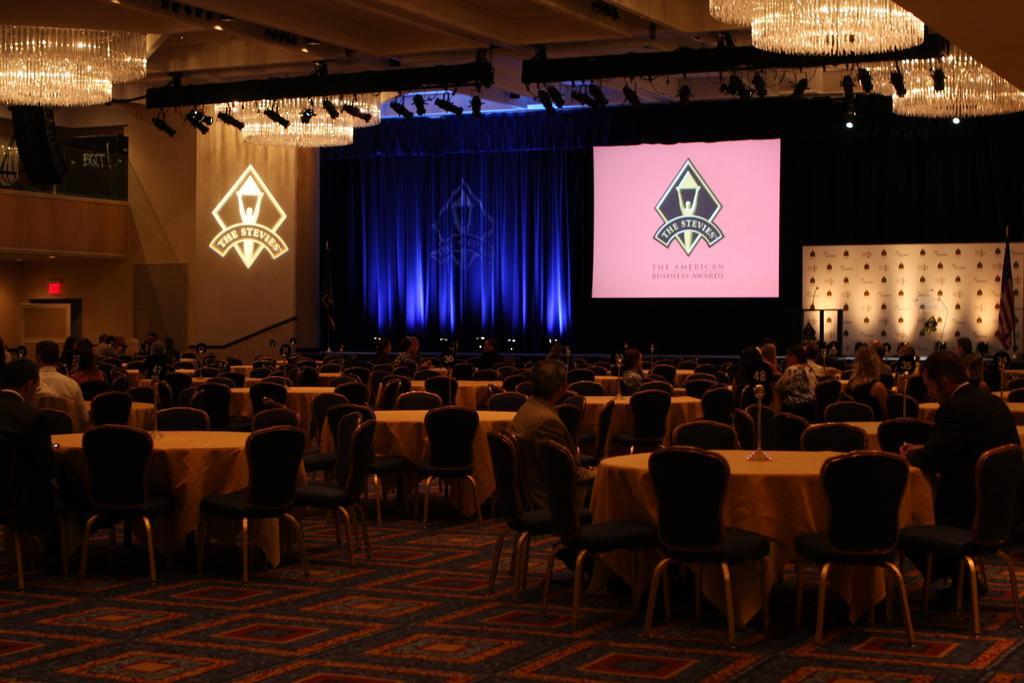Can you describe this image briefly? Here we can see a hall full of tables and chairs and people sitting on them, at the top we can see few chandeliers and in the center we can see a projector screen and beside that we can see a blue curtain 